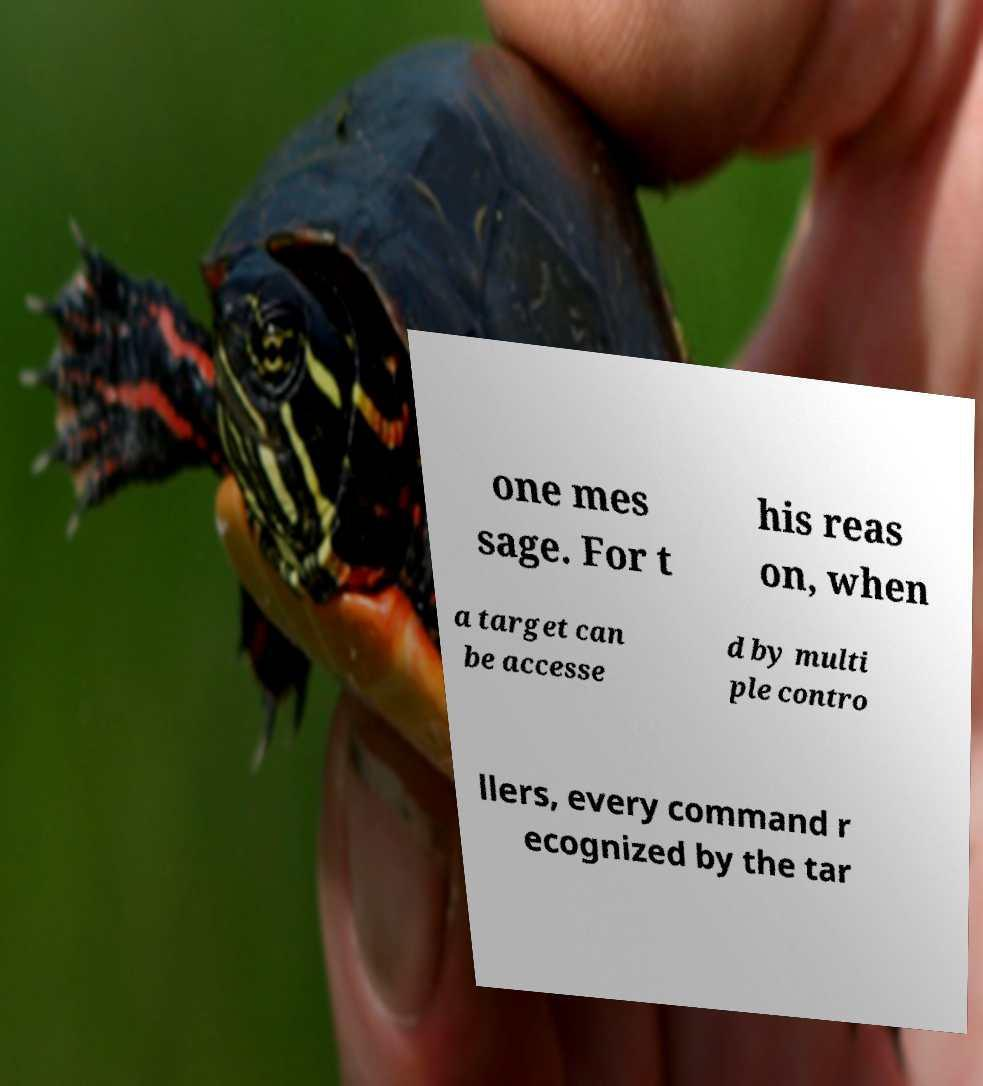There's text embedded in this image that I need extracted. Can you transcribe it verbatim? one mes sage. For t his reas on, when a target can be accesse d by multi ple contro llers, every command r ecognized by the tar 